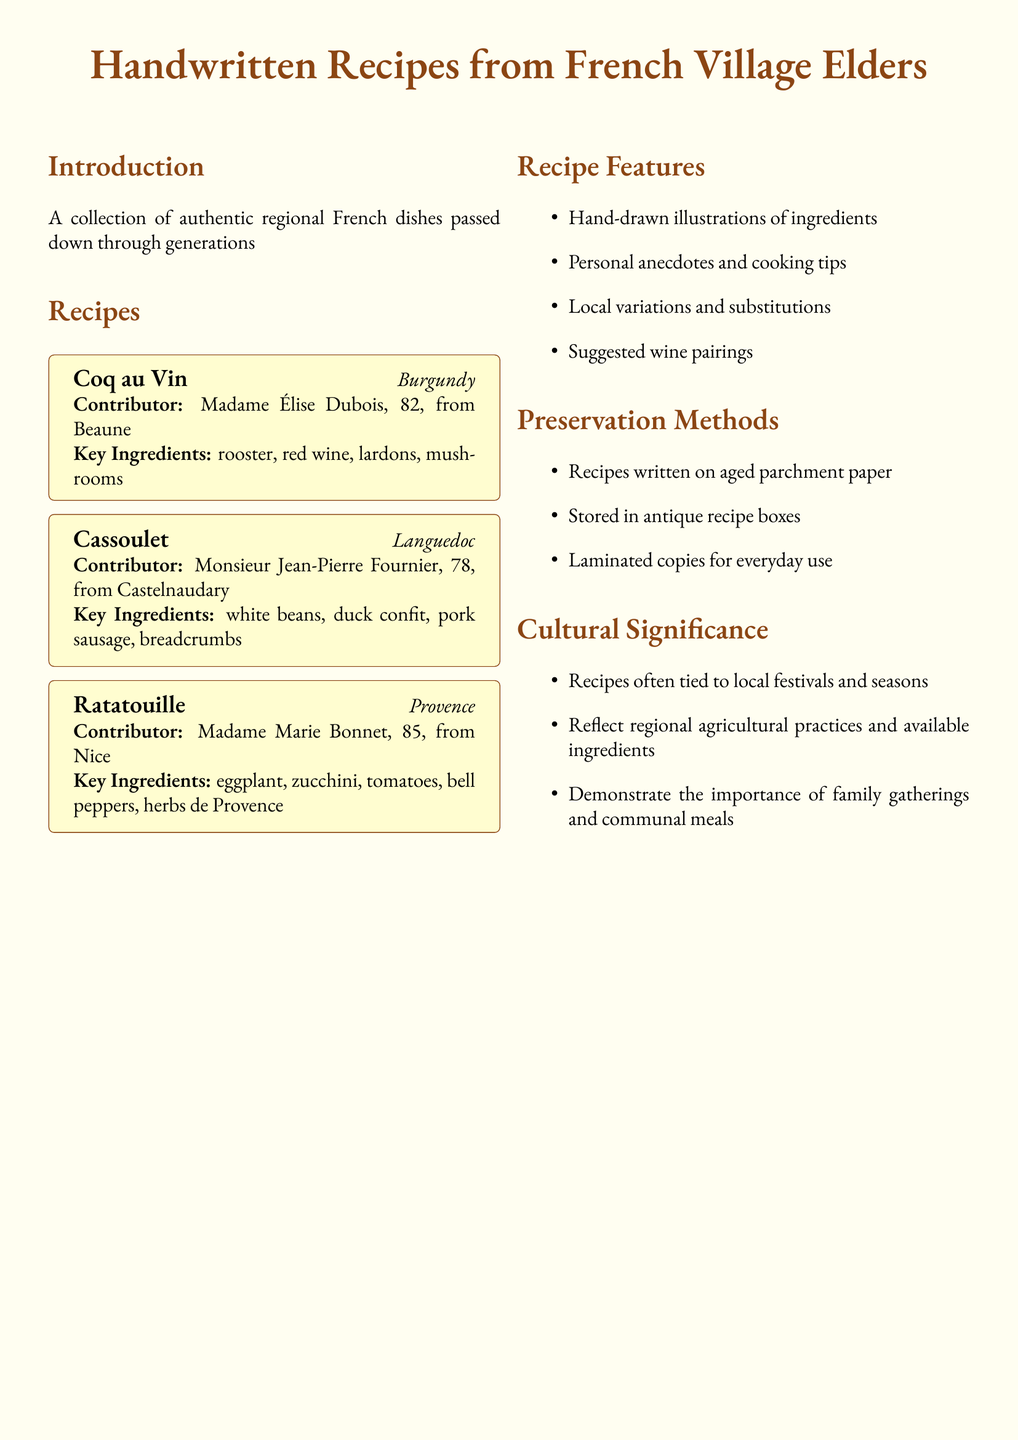What is the origin of Coq au Vin? The recipe for Coq au Vin is from the region of Burgundy.
Answer: Burgundy Who contributed the Cassoulet recipe? The recipe for Cassoulet was contributed by Monsieur Jean-Pierre Fournier.
Answer: Monsieur Jean-Pierre Fournier What key ingredient is common in Ratatouille? Ratatouille includes eggplant as one of its key ingredients.
Answer: eggplant What is a cultural significance of the recipes? Recipes are tied to local festivals and seasons, reflecting cultural traditions.
Answer: local festivals and seasons How many recipes are included in the document? The document contains a total of three recipes.
Answer: three What type of paper are the recipes written on? The recipes are written on aged parchment paper.
Answer: aged parchment paper What is included in the recipe features? Hand-drawn illustrations of ingredients are included in the recipe features.
Answer: Hand-drawn illustrations of ingredients How old is Madame Marie Bonnet? Madame Marie Bonnet is 85 years old.
Answer: 85 What preservation method involves antique items? Recipes are stored in antique recipe boxes as a preservation method.
Answer: antique recipe boxes 